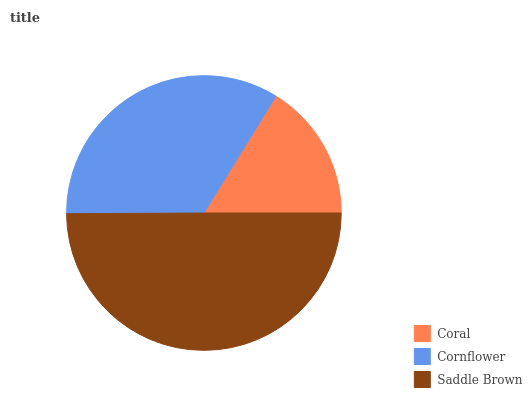Is Coral the minimum?
Answer yes or no. Yes. Is Saddle Brown the maximum?
Answer yes or no. Yes. Is Cornflower the minimum?
Answer yes or no. No. Is Cornflower the maximum?
Answer yes or no. No. Is Cornflower greater than Coral?
Answer yes or no. Yes. Is Coral less than Cornflower?
Answer yes or no. Yes. Is Coral greater than Cornflower?
Answer yes or no. No. Is Cornflower less than Coral?
Answer yes or no. No. Is Cornflower the high median?
Answer yes or no. Yes. Is Cornflower the low median?
Answer yes or no. Yes. Is Saddle Brown the high median?
Answer yes or no. No. Is Saddle Brown the low median?
Answer yes or no. No. 